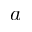Convert formula to latex. <formula><loc_0><loc_0><loc_500><loc_500>a</formula> 